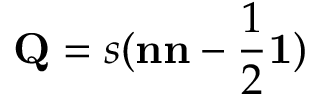Convert formula to latex. <formula><loc_0><loc_0><loc_500><loc_500>Q = s ( n n - \frac { 1 } { 2 } 1 )</formula> 